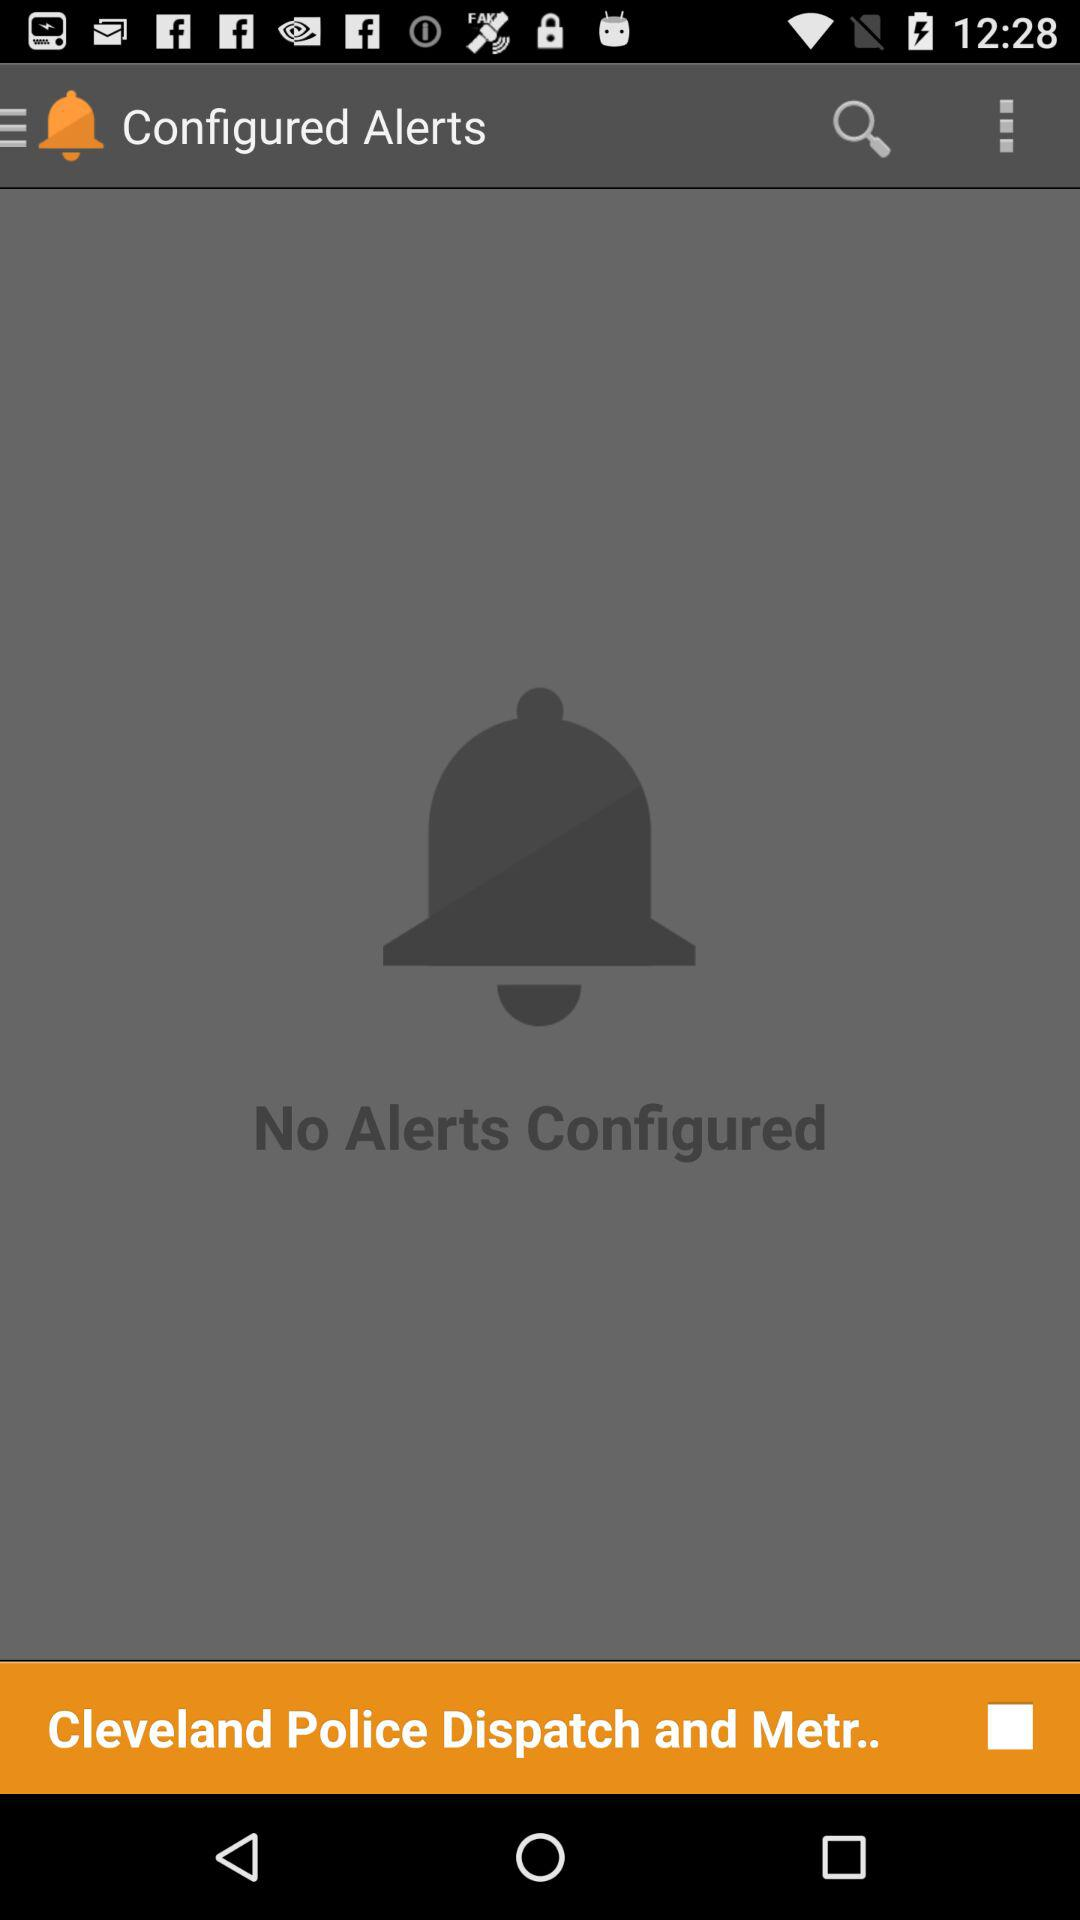How many alerts are configured? There are no alerts configured. 